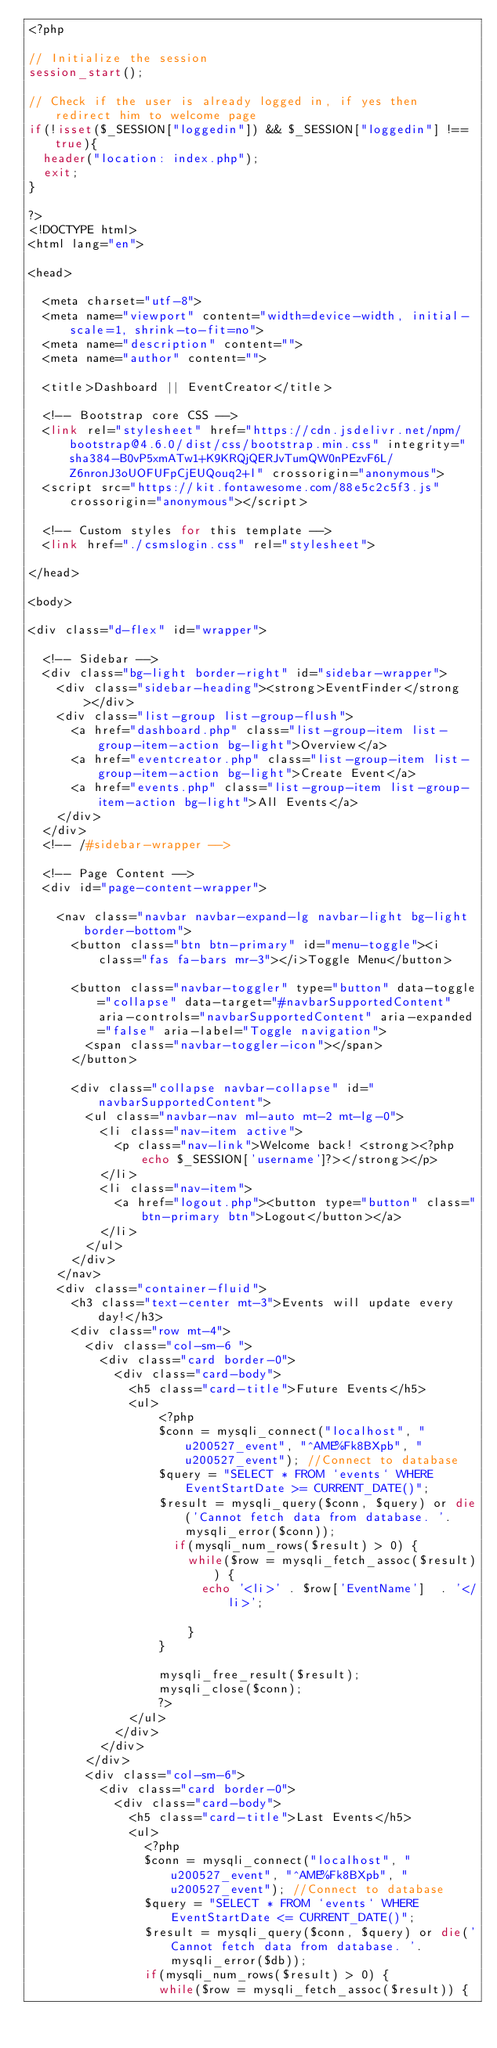Convert code to text. <code><loc_0><loc_0><loc_500><loc_500><_PHP_><?php

// Initialize the session
session_start();

// Check if the user is already logged in, if yes then redirect him to welcome page
if(!isset($_SESSION["loggedin"]) && $_SESSION["loggedin"] !== true){
  header("location: index.php");
  exit;
}

?>
<!DOCTYPE html>
<html lang="en">

<head>

  <meta charset="utf-8">
  <meta name="viewport" content="width=device-width, initial-scale=1, shrink-to-fit=no">
  <meta name="description" content="">
  <meta name="author" content="">

  <title>Dashboard || EventCreator</title>

  <!-- Bootstrap core CSS -->
  <link rel="stylesheet" href="https://cdn.jsdelivr.net/npm/bootstrap@4.6.0/dist/css/bootstrap.min.css" integrity="sha384-B0vP5xmATw1+K9KRQjQERJvTumQW0nPEzvF6L/Z6nronJ3oUOFUFpCjEUQouq2+l" crossorigin="anonymous">
  <script src="https://kit.fontawesome.com/88e5c2c5f3.js" crossorigin="anonymous"></script>

  <!-- Custom styles for this template -->
  <link href="./csmslogin.css" rel="stylesheet">

</head>

<body>

<div class="d-flex" id="wrapper">

  <!-- Sidebar -->
  <div class="bg-light border-right" id="sidebar-wrapper">
    <div class="sidebar-heading"><strong>EventFinder</strong></div>
    <div class="list-group list-group-flush">
      <a href="dashboard.php" class="list-group-item list-group-item-action bg-light">Overview</a>
      <a href="eventcreator.php" class="list-group-item list-group-item-action bg-light">Create Event</a>
      <a href="events.php" class="list-group-item list-group-item-action bg-light">All Events</a>
    </div>
  </div>
  <!-- /#sidebar-wrapper -->

  <!-- Page Content -->
  <div id="page-content-wrapper">

    <nav class="navbar navbar-expand-lg navbar-light bg-light border-bottom">
      <button class="btn btn-primary" id="menu-toggle"><i class="fas fa-bars mr-3"></i>Toggle Menu</button>

      <button class="navbar-toggler" type="button" data-toggle="collapse" data-target="#navbarSupportedContent" aria-controls="navbarSupportedContent" aria-expanded="false" aria-label="Toggle navigation">
        <span class="navbar-toggler-icon"></span>
      </button>

      <div class="collapse navbar-collapse" id="navbarSupportedContent">
        <ul class="navbar-nav ml-auto mt-2 mt-lg-0">
          <li class="nav-item active">
            <p class="nav-link">Welcome back! <strong><?php echo $_SESSION['username']?></strong></p>
          </li>
          <li class="nav-item">
            <a href="logout.php"><button type="button" class="btn-primary btn">Logout</button></a>
          </li>
        </ul>
      </div>
    </nav>
    <div class="container-fluid">
      <h3 class="text-center mt-3">Events will update every day!</h3>
      <div class="row mt-4">
        <div class="col-sm-6 ">
          <div class="card border-0">
            <div class="card-body">
              <h5 class="card-title">Future Events</h5>
              <ul>
                  <?php
                  $conn = mysqli_connect("localhost", "u200527_event", "^AME%Fk8BXpb", "u200527_event"); //Connect to database
                  $query = "SELECT * FROM `events` WHERE EventStartDate >= CURRENT_DATE()";
                  $result = mysqli_query($conn, $query) or die('Cannot fetch data from database. '.mysqli_error($conn));
                    if(mysqli_num_rows($result) > 0) {
                      while($row = mysqli_fetch_assoc($result)) {
                        echo '<li>' . $row['EventName']  . '</li>';

                      }
                  }

                  mysqli_free_result($result);
                  mysqli_close($conn);
                  ?>
              </ul>
            </div>
          </div>
        </div>
        <div class="col-sm-6">
          <div class="card border-0">
            <div class="card-body">
              <h5 class="card-title">Last Events</h5>
              <ul>
                <?php
                $conn = mysqli_connect("localhost", "u200527_event", "^AME%Fk8BXpb", "u200527_event"); //Connect to database
                $query = "SELECT * FROM `events` WHERE EventStartDate <= CURRENT_DATE()";
                $result = mysqli_query($conn, $query) or die('Cannot fetch data from database. '.mysqli_error($db));
                if(mysqli_num_rows($result) > 0) {
                  while($row = mysqli_fetch_assoc($result)) {</code> 